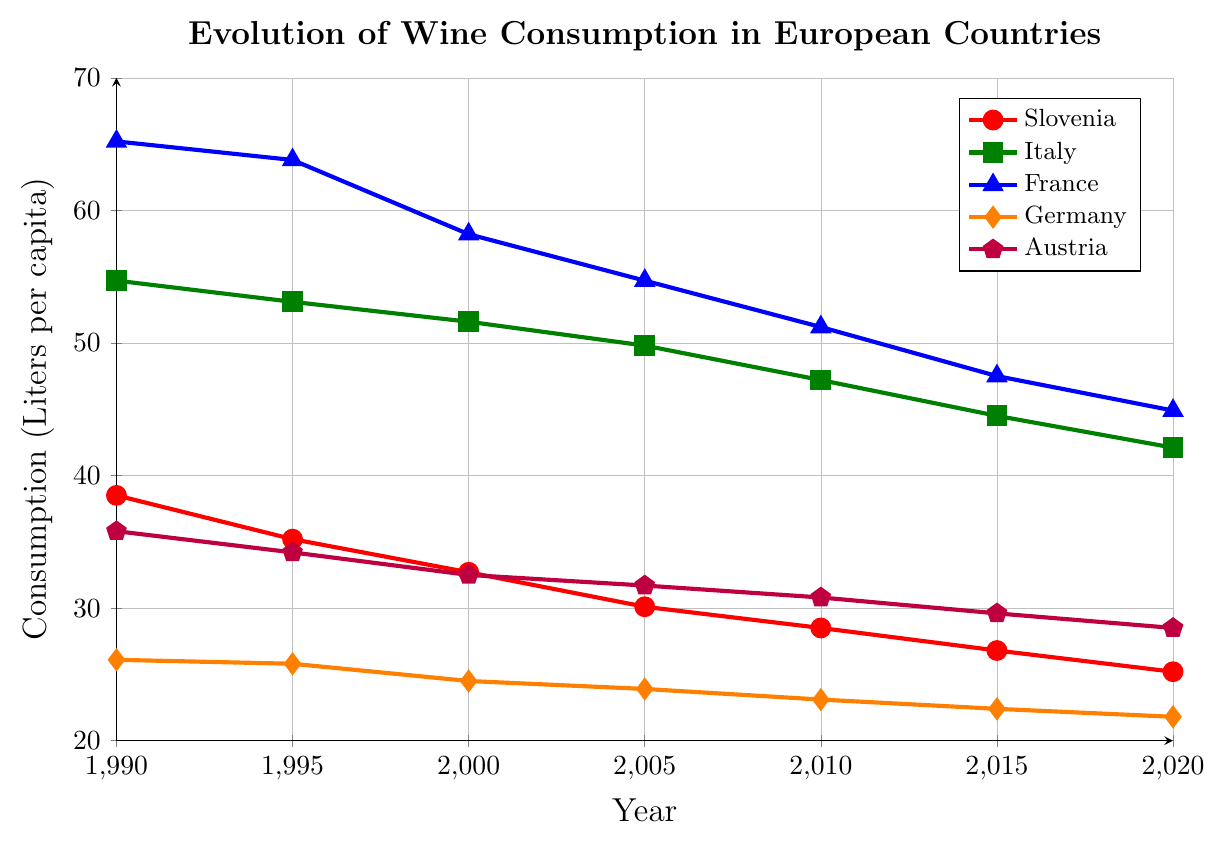what is the overall trend of wine consumption in Slovenia from 1990 to 2020? Observing the red line for Slovenia in the plot, we see a steady decline in wine consumption over the given years.
Answer: declining Which country had the highest wine consumption in 1990? From the plot, the blue line representing France is the highest in 1990.
Answer: France By how much did wine consumption in Slovenia decrease from 1990 to 2020? Wine consumption in Slovenia dropped from 38.5 liters per capita in 1990 to 25.2 liters per capita in 2020. The decrease is 38.5 - 25.2 = 13.3 liters per capita.
Answer: 13.3 liters Comparing 2010, which country had the closest wine consumption to Slovenia? In 2010, observing the lines, Austria's (purple line) wine consumption is 30.8 liters, while Slovenia's (red line) is 28.5 liters per capita, making Austria the closest.
Answer: Austria What was the average wine consumption in Germany between 1990 and 2020? Sum up the values for Germany (orange line): 26.1 (1990) + 25.8 (1995) + 24.5 (2000) + 23.9 (2005) + 23.1 (2010) + 22.4 (2015) + 21.8 (2020). Average is (26.1 + 25.8 + 24.5 + 23.9 + 23.1 + 22.4 + 21.8) / 7 ≈ 23.7
Answer: 23.7 liters Which country showed the least decrease in wine consumption from 1990 to 2020? Observing the plot lines, Germany's (orange line) consumption decreased from 26.1 in 1990 to 21.8 in 2020, a difference of 26.1 - 21.8 = 4.3 liters, which is the smallest decrease among the countries.
Answer: Germany In which year did France's wine consumption fall below 50 liters per capita? Examining the blue line for France, it falls below 50 liters per capita between 2005 and 2010. Since it is 51.2 in 2010, it must have fallen below 50 after 2005 but before 2010.
Answer: Between 2005 and 2010 What is the difference in wine consumption between France and Italy in 2020? In 2020, France's wine consumption (blue line) is 44.9 liters per capita, and Italy's (green line) is 42.1 liters per capita. The difference is 44.9 - 42.1 = 2.8 liters.
Answer: 2.8 liters Which country had a consumption just below Slovenia in 1990? In 1990, Germany’s (orange line) consumption is 26.1 liters per capita, which is significantly lower than Slovenia at 38.5 liters. The closest consumption below Slovenia in 1990 is Austria (purple line) with 35.8 liters per capita.
Answer: Austria Which year saw Italy's wine consumption drop below 50 liters per capita? Observing the green line for Italy, it is 49.8 liters in 2005, so it fell below 50 liters per capita between 2000 and 2005.
Answer: Between 2000 and 2005 